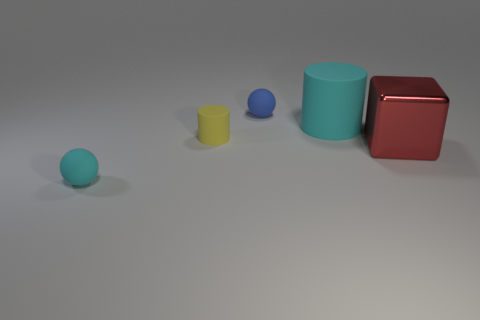How many things are spheres that are to the right of the small cyan matte thing or small metallic cylinders?
Keep it short and to the point. 1. The cyan matte object that is right of the rubber ball in front of the metal cube is what shape?
Your answer should be compact. Cylinder. There is a red block; is its size the same as the cyan thing that is in front of the big red object?
Your response must be concise. No. What is the cyan object that is behind the cyan matte ball made of?
Your response must be concise. Rubber. What number of cyan rubber things are in front of the large cube and right of the blue thing?
Provide a succinct answer. 0. There is a cyan thing that is the same size as the red object; what is its material?
Offer a very short reply. Rubber. There is a thing that is in front of the red metal block; is its size the same as the cyan rubber object to the right of the blue matte sphere?
Give a very brief answer. No. There is a tiny cylinder; are there any objects left of it?
Your answer should be compact. Yes. What is the color of the tiny thing that is on the right side of the small cylinder that is behind the metallic cube?
Provide a succinct answer. Blue. Is the number of big metal cylinders less than the number of small yellow objects?
Your response must be concise. Yes. 